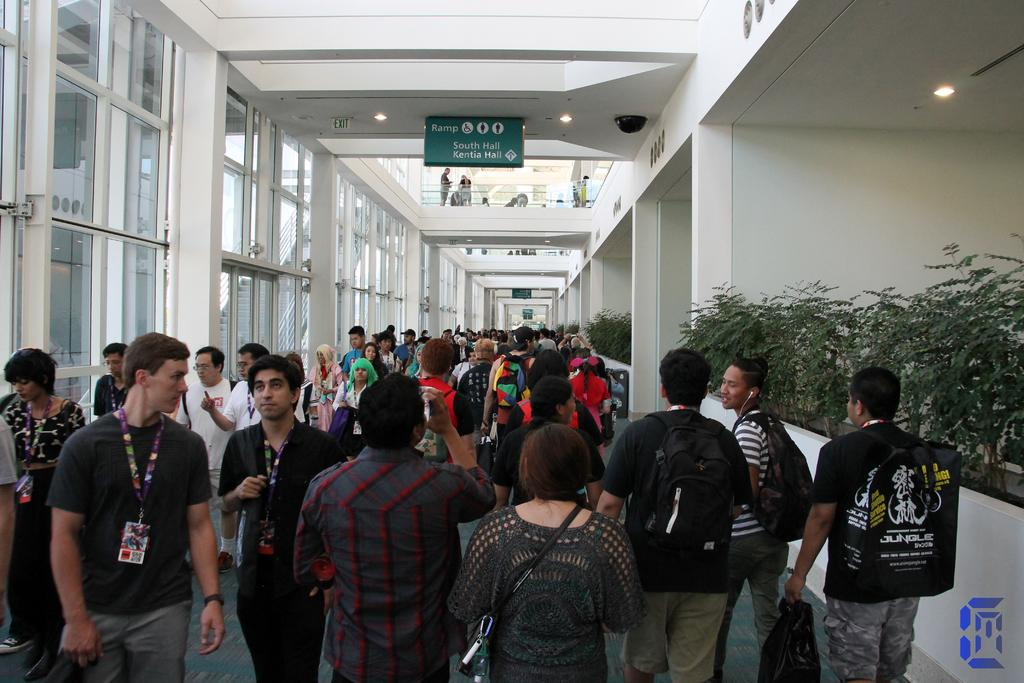What is happening with the group of people in the image? The group of people is on the floor. What type of vegetation can be seen in the image? There are plants in the image. What can be seen in the background of the image? There are walls and people in the background of the image. What type of lighting is present in the image? There are lights in the image. What objects are visible in the image? There are some objects in the image. Can you describe the windows in the image? There are windows in the image. What type of horn can be heard in the image? There is no horn present in the image, and therefore no sound can be heard. 